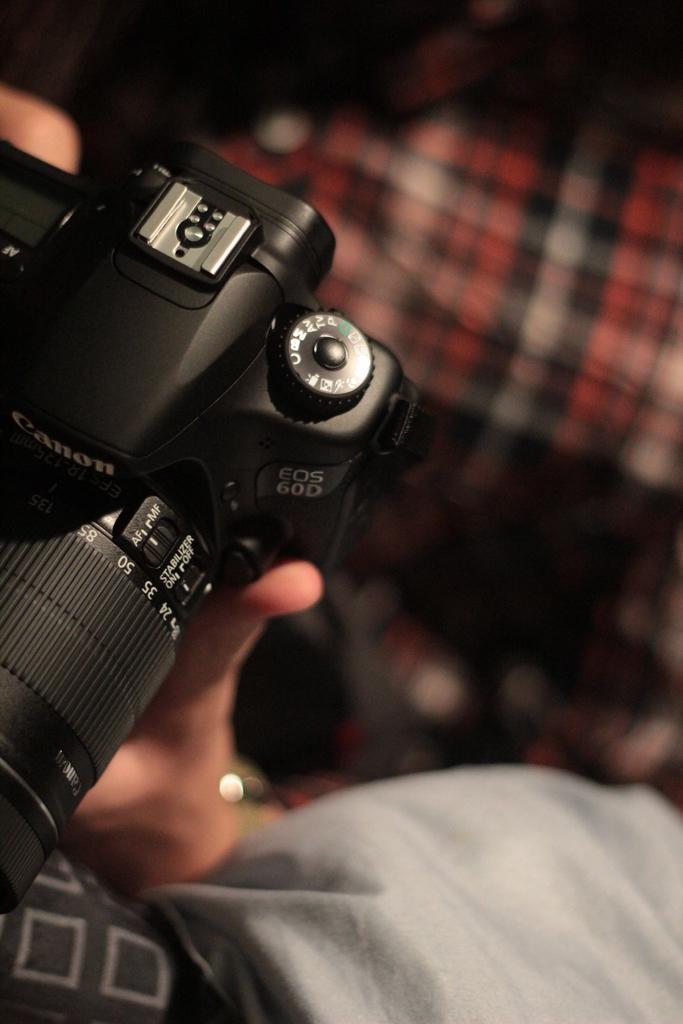Describe this image in one or two sentences. At the left side of the image there is a black camera. And at the right side there is a blur image. 